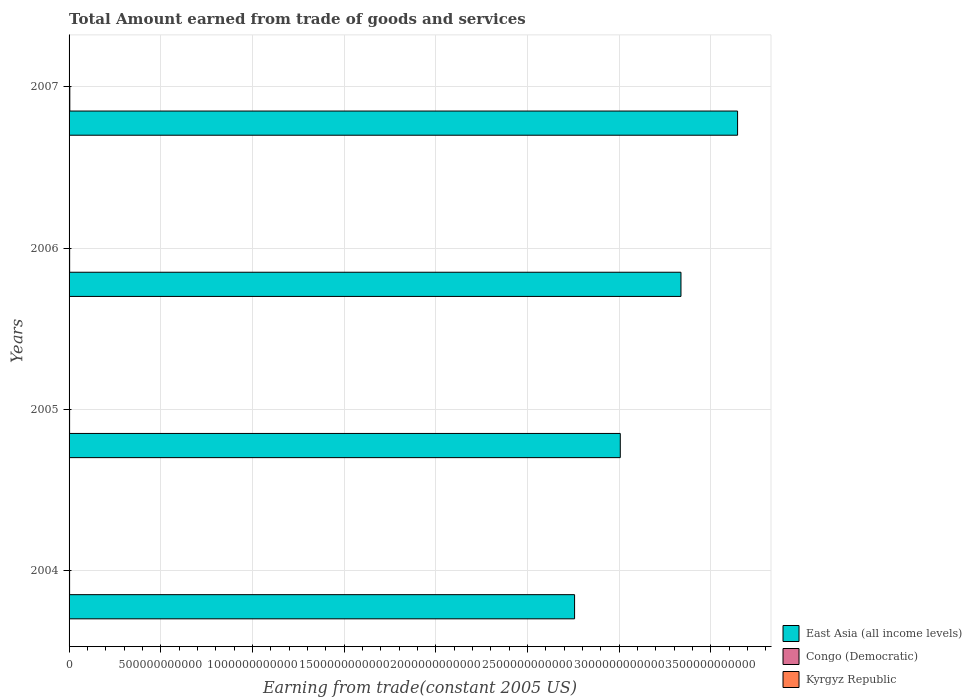How many different coloured bars are there?
Your answer should be very brief. 3. How many groups of bars are there?
Offer a very short reply. 4. How many bars are there on the 1st tick from the top?
Offer a terse response. 3. In how many cases, is the number of bars for a given year not equal to the number of legend labels?
Your response must be concise. 0. What is the total amount earned by trading goods and services in East Asia (all income levels) in 2007?
Provide a short and direct response. 3.65e+12. Across all years, what is the maximum total amount earned by trading goods and services in East Asia (all income levels)?
Offer a very short reply. 3.65e+12. Across all years, what is the minimum total amount earned by trading goods and services in Congo (Democratic)?
Your response must be concise. 2.82e+09. In which year was the total amount earned by trading goods and services in Kyrgyz Republic minimum?
Ensure brevity in your answer.  2004. What is the total total amount earned by trading goods and services in Congo (Democratic) in the graph?
Make the answer very short. 1.28e+1. What is the difference between the total amount earned by trading goods and services in East Asia (all income levels) in 2004 and that in 2007?
Provide a short and direct response. -8.89e+11. What is the difference between the total amount earned by trading goods and services in East Asia (all income levels) in 2004 and the total amount earned by trading goods and services in Congo (Democratic) in 2007?
Your answer should be compact. 2.75e+12. What is the average total amount earned by trading goods and services in East Asia (all income levels) per year?
Give a very brief answer. 3.19e+12. In the year 2005, what is the difference between the total amount earned by trading goods and services in Kyrgyz Republic and total amount earned by trading goods and services in East Asia (all income levels)?
Ensure brevity in your answer.  -3.00e+12. In how many years, is the total amount earned by trading goods and services in East Asia (all income levels) greater than 800000000000 US$?
Make the answer very short. 4. What is the ratio of the total amount earned by trading goods and services in East Asia (all income levels) in 2005 to that in 2006?
Offer a terse response. 0.9. What is the difference between the highest and the second highest total amount earned by trading goods and services in East Asia (all income levels)?
Give a very brief answer. 3.09e+11. What is the difference between the highest and the lowest total amount earned by trading goods and services in East Asia (all income levels)?
Ensure brevity in your answer.  8.89e+11. In how many years, is the total amount earned by trading goods and services in Congo (Democratic) greater than the average total amount earned by trading goods and services in Congo (Democratic) taken over all years?
Your answer should be compact. 1. What does the 3rd bar from the top in 2007 represents?
Your response must be concise. East Asia (all income levels). What does the 1st bar from the bottom in 2007 represents?
Offer a very short reply. East Asia (all income levels). Is it the case that in every year, the sum of the total amount earned by trading goods and services in Congo (Democratic) and total amount earned by trading goods and services in East Asia (all income levels) is greater than the total amount earned by trading goods and services in Kyrgyz Republic?
Keep it short and to the point. Yes. What is the difference between two consecutive major ticks on the X-axis?
Your answer should be very brief. 5.00e+11. Where does the legend appear in the graph?
Your answer should be compact. Bottom right. How are the legend labels stacked?
Make the answer very short. Vertical. What is the title of the graph?
Provide a short and direct response. Total Amount earned from trade of goods and services. Does "Burundi" appear as one of the legend labels in the graph?
Your answer should be very brief. No. What is the label or title of the X-axis?
Offer a very short reply. Earning from trade(constant 2005 US). What is the label or title of the Y-axis?
Ensure brevity in your answer.  Years. What is the Earning from trade(constant 2005 US) of East Asia (all income levels) in 2004?
Offer a very short reply. 2.76e+12. What is the Earning from trade(constant 2005 US) of Congo (Democratic) in 2004?
Provide a short and direct response. 2.84e+09. What is the Earning from trade(constant 2005 US) in Kyrgyz Republic in 2004?
Your response must be concise. 1.31e+09. What is the Earning from trade(constant 2005 US) of East Asia (all income levels) in 2005?
Provide a succinct answer. 3.01e+12. What is the Earning from trade(constant 2005 US) of Congo (Democratic) in 2005?
Provide a succinct answer. 2.82e+09. What is the Earning from trade(constant 2005 US) in Kyrgyz Republic in 2005?
Make the answer very short. 1.40e+09. What is the Earning from trade(constant 2005 US) in East Asia (all income levels) in 2006?
Ensure brevity in your answer.  3.34e+12. What is the Earning from trade(constant 2005 US) in Congo (Democratic) in 2006?
Your answer should be very brief. 3.10e+09. What is the Earning from trade(constant 2005 US) in Kyrgyz Republic in 2006?
Your response must be concise. 2.03e+09. What is the Earning from trade(constant 2005 US) of East Asia (all income levels) in 2007?
Your answer should be very brief. 3.65e+12. What is the Earning from trade(constant 2005 US) in Congo (Democratic) in 2007?
Your answer should be compact. 4.03e+09. What is the Earning from trade(constant 2005 US) in Kyrgyz Republic in 2007?
Offer a very short reply. 2.25e+09. Across all years, what is the maximum Earning from trade(constant 2005 US) of East Asia (all income levels)?
Keep it short and to the point. 3.65e+12. Across all years, what is the maximum Earning from trade(constant 2005 US) in Congo (Democratic)?
Offer a very short reply. 4.03e+09. Across all years, what is the maximum Earning from trade(constant 2005 US) of Kyrgyz Republic?
Ensure brevity in your answer.  2.25e+09. Across all years, what is the minimum Earning from trade(constant 2005 US) of East Asia (all income levels)?
Give a very brief answer. 2.76e+12. Across all years, what is the minimum Earning from trade(constant 2005 US) in Congo (Democratic)?
Provide a short and direct response. 2.82e+09. Across all years, what is the minimum Earning from trade(constant 2005 US) in Kyrgyz Republic?
Ensure brevity in your answer.  1.31e+09. What is the total Earning from trade(constant 2005 US) in East Asia (all income levels) in the graph?
Offer a terse response. 1.27e+13. What is the total Earning from trade(constant 2005 US) in Congo (Democratic) in the graph?
Offer a very short reply. 1.28e+1. What is the total Earning from trade(constant 2005 US) of Kyrgyz Republic in the graph?
Make the answer very short. 6.98e+09. What is the difference between the Earning from trade(constant 2005 US) in East Asia (all income levels) in 2004 and that in 2005?
Your answer should be compact. -2.49e+11. What is the difference between the Earning from trade(constant 2005 US) in Congo (Democratic) in 2004 and that in 2005?
Provide a succinct answer. 2.57e+07. What is the difference between the Earning from trade(constant 2005 US) in Kyrgyz Republic in 2004 and that in 2005?
Your answer should be very brief. -8.49e+07. What is the difference between the Earning from trade(constant 2005 US) of East Asia (all income levels) in 2004 and that in 2006?
Your answer should be compact. -5.80e+11. What is the difference between the Earning from trade(constant 2005 US) of Congo (Democratic) in 2004 and that in 2006?
Offer a very short reply. -2.57e+08. What is the difference between the Earning from trade(constant 2005 US) of Kyrgyz Republic in 2004 and that in 2006?
Give a very brief answer. -7.13e+08. What is the difference between the Earning from trade(constant 2005 US) of East Asia (all income levels) in 2004 and that in 2007?
Make the answer very short. -8.89e+11. What is the difference between the Earning from trade(constant 2005 US) of Congo (Democratic) in 2004 and that in 2007?
Offer a very short reply. -1.19e+09. What is the difference between the Earning from trade(constant 2005 US) of Kyrgyz Republic in 2004 and that in 2007?
Offer a very short reply. -9.36e+08. What is the difference between the Earning from trade(constant 2005 US) of East Asia (all income levels) in 2005 and that in 2006?
Ensure brevity in your answer.  -3.31e+11. What is the difference between the Earning from trade(constant 2005 US) in Congo (Democratic) in 2005 and that in 2006?
Provide a succinct answer. -2.82e+08. What is the difference between the Earning from trade(constant 2005 US) of Kyrgyz Republic in 2005 and that in 2006?
Make the answer very short. -6.28e+08. What is the difference between the Earning from trade(constant 2005 US) of East Asia (all income levels) in 2005 and that in 2007?
Provide a succinct answer. -6.40e+11. What is the difference between the Earning from trade(constant 2005 US) of Congo (Democratic) in 2005 and that in 2007?
Provide a short and direct response. -1.21e+09. What is the difference between the Earning from trade(constant 2005 US) of Kyrgyz Republic in 2005 and that in 2007?
Your answer should be compact. -8.51e+08. What is the difference between the Earning from trade(constant 2005 US) of East Asia (all income levels) in 2006 and that in 2007?
Offer a very short reply. -3.09e+11. What is the difference between the Earning from trade(constant 2005 US) in Congo (Democratic) in 2006 and that in 2007?
Your answer should be very brief. -9.32e+08. What is the difference between the Earning from trade(constant 2005 US) in Kyrgyz Republic in 2006 and that in 2007?
Ensure brevity in your answer.  -2.23e+08. What is the difference between the Earning from trade(constant 2005 US) of East Asia (all income levels) in 2004 and the Earning from trade(constant 2005 US) of Congo (Democratic) in 2005?
Your answer should be compact. 2.75e+12. What is the difference between the Earning from trade(constant 2005 US) in East Asia (all income levels) in 2004 and the Earning from trade(constant 2005 US) in Kyrgyz Republic in 2005?
Offer a very short reply. 2.76e+12. What is the difference between the Earning from trade(constant 2005 US) of Congo (Democratic) in 2004 and the Earning from trade(constant 2005 US) of Kyrgyz Republic in 2005?
Offer a very short reply. 1.45e+09. What is the difference between the Earning from trade(constant 2005 US) in East Asia (all income levels) in 2004 and the Earning from trade(constant 2005 US) in Congo (Democratic) in 2006?
Offer a very short reply. 2.75e+12. What is the difference between the Earning from trade(constant 2005 US) of East Asia (all income levels) in 2004 and the Earning from trade(constant 2005 US) of Kyrgyz Republic in 2006?
Provide a succinct answer. 2.75e+12. What is the difference between the Earning from trade(constant 2005 US) in Congo (Democratic) in 2004 and the Earning from trade(constant 2005 US) in Kyrgyz Republic in 2006?
Provide a succinct answer. 8.19e+08. What is the difference between the Earning from trade(constant 2005 US) of East Asia (all income levels) in 2004 and the Earning from trade(constant 2005 US) of Congo (Democratic) in 2007?
Your response must be concise. 2.75e+12. What is the difference between the Earning from trade(constant 2005 US) of East Asia (all income levels) in 2004 and the Earning from trade(constant 2005 US) of Kyrgyz Republic in 2007?
Provide a short and direct response. 2.75e+12. What is the difference between the Earning from trade(constant 2005 US) of Congo (Democratic) in 2004 and the Earning from trade(constant 2005 US) of Kyrgyz Republic in 2007?
Provide a short and direct response. 5.96e+08. What is the difference between the Earning from trade(constant 2005 US) of East Asia (all income levels) in 2005 and the Earning from trade(constant 2005 US) of Congo (Democratic) in 2006?
Keep it short and to the point. 3.00e+12. What is the difference between the Earning from trade(constant 2005 US) of East Asia (all income levels) in 2005 and the Earning from trade(constant 2005 US) of Kyrgyz Republic in 2006?
Provide a short and direct response. 3.00e+12. What is the difference between the Earning from trade(constant 2005 US) in Congo (Democratic) in 2005 and the Earning from trade(constant 2005 US) in Kyrgyz Republic in 2006?
Offer a terse response. 7.94e+08. What is the difference between the Earning from trade(constant 2005 US) of East Asia (all income levels) in 2005 and the Earning from trade(constant 2005 US) of Congo (Democratic) in 2007?
Offer a very short reply. 3.00e+12. What is the difference between the Earning from trade(constant 2005 US) of East Asia (all income levels) in 2005 and the Earning from trade(constant 2005 US) of Kyrgyz Republic in 2007?
Keep it short and to the point. 3.00e+12. What is the difference between the Earning from trade(constant 2005 US) in Congo (Democratic) in 2005 and the Earning from trade(constant 2005 US) in Kyrgyz Republic in 2007?
Keep it short and to the point. 5.71e+08. What is the difference between the Earning from trade(constant 2005 US) of East Asia (all income levels) in 2006 and the Earning from trade(constant 2005 US) of Congo (Democratic) in 2007?
Your answer should be very brief. 3.33e+12. What is the difference between the Earning from trade(constant 2005 US) of East Asia (all income levels) in 2006 and the Earning from trade(constant 2005 US) of Kyrgyz Republic in 2007?
Provide a succinct answer. 3.33e+12. What is the difference between the Earning from trade(constant 2005 US) of Congo (Democratic) in 2006 and the Earning from trade(constant 2005 US) of Kyrgyz Republic in 2007?
Provide a short and direct response. 8.53e+08. What is the average Earning from trade(constant 2005 US) in East Asia (all income levels) per year?
Offer a very short reply. 3.19e+12. What is the average Earning from trade(constant 2005 US) in Congo (Democratic) per year?
Keep it short and to the point. 3.20e+09. What is the average Earning from trade(constant 2005 US) in Kyrgyz Republic per year?
Provide a succinct answer. 1.75e+09. In the year 2004, what is the difference between the Earning from trade(constant 2005 US) of East Asia (all income levels) and Earning from trade(constant 2005 US) of Congo (Democratic)?
Provide a short and direct response. 2.75e+12. In the year 2004, what is the difference between the Earning from trade(constant 2005 US) in East Asia (all income levels) and Earning from trade(constant 2005 US) in Kyrgyz Republic?
Your answer should be very brief. 2.76e+12. In the year 2004, what is the difference between the Earning from trade(constant 2005 US) of Congo (Democratic) and Earning from trade(constant 2005 US) of Kyrgyz Republic?
Ensure brevity in your answer.  1.53e+09. In the year 2005, what is the difference between the Earning from trade(constant 2005 US) of East Asia (all income levels) and Earning from trade(constant 2005 US) of Congo (Democratic)?
Provide a succinct answer. 3.00e+12. In the year 2005, what is the difference between the Earning from trade(constant 2005 US) in East Asia (all income levels) and Earning from trade(constant 2005 US) in Kyrgyz Republic?
Give a very brief answer. 3.00e+12. In the year 2005, what is the difference between the Earning from trade(constant 2005 US) of Congo (Democratic) and Earning from trade(constant 2005 US) of Kyrgyz Republic?
Give a very brief answer. 1.42e+09. In the year 2006, what is the difference between the Earning from trade(constant 2005 US) of East Asia (all income levels) and Earning from trade(constant 2005 US) of Congo (Democratic)?
Offer a terse response. 3.33e+12. In the year 2006, what is the difference between the Earning from trade(constant 2005 US) of East Asia (all income levels) and Earning from trade(constant 2005 US) of Kyrgyz Republic?
Your response must be concise. 3.33e+12. In the year 2006, what is the difference between the Earning from trade(constant 2005 US) of Congo (Democratic) and Earning from trade(constant 2005 US) of Kyrgyz Republic?
Offer a very short reply. 1.08e+09. In the year 2007, what is the difference between the Earning from trade(constant 2005 US) in East Asia (all income levels) and Earning from trade(constant 2005 US) in Congo (Democratic)?
Provide a succinct answer. 3.64e+12. In the year 2007, what is the difference between the Earning from trade(constant 2005 US) of East Asia (all income levels) and Earning from trade(constant 2005 US) of Kyrgyz Republic?
Offer a very short reply. 3.64e+12. In the year 2007, what is the difference between the Earning from trade(constant 2005 US) of Congo (Democratic) and Earning from trade(constant 2005 US) of Kyrgyz Republic?
Your answer should be compact. 1.79e+09. What is the ratio of the Earning from trade(constant 2005 US) of East Asia (all income levels) in 2004 to that in 2005?
Your answer should be very brief. 0.92. What is the ratio of the Earning from trade(constant 2005 US) of Congo (Democratic) in 2004 to that in 2005?
Your answer should be very brief. 1.01. What is the ratio of the Earning from trade(constant 2005 US) in Kyrgyz Republic in 2004 to that in 2005?
Your answer should be compact. 0.94. What is the ratio of the Earning from trade(constant 2005 US) in East Asia (all income levels) in 2004 to that in 2006?
Provide a succinct answer. 0.83. What is the ratio of the Earning from trade(constant 2005 US) in Congo (Democratic) in 2004 to that in 2006?
Ensure brevity in your answer.  0.92. What is the ratio of the Earning from trade(constant 2005 US) of Kyrgyz Republic in 2004 to that in 2006?
Your answer should be very brief. 0.65. What is the ratio of the Earning from trade(constant 2005 US) of East Asia (all income levels) in 2004 to that in 2007?
Give a very brief answer. 0.76. What is the ratio of the Earning from trade(constant 2005 US) in Congo (Democratic) in 2004 to that in 2007?
Your answer should be very brief. 0.71. What is the ratio of the Earning from trade(constant 2005 US) of Kyrgyz Republic in 2004 to that in 2007?
Ensure brevity in your answer.  0.58. What is the ratio of the Earning from trade(constant 2005 US) in East Asia (all income levels) in 2005 to that in 2006?
Your answer should be compact. 0.9. What is the ratio of the Earning from trade(constant 2005 US) of Congo (Democratic) in 2005 to that in 2006?
Ensure brevity in your answer.  0.91. What is the ratio of the Earning from trade(constant 2005 US) in Kyrgyz Republic in 2005 to that in 2006?
Keep it short and to the point. 0.69. What is the ratio of the Earning from trade(constant 2005 US) in East Asia (all income levels) in 2005 to that in 2007?
Provide a short and direct response. 0.82. What is the ratio of the Earning from trade(constant 2005 US) of Congo (Democratic) in 2005 to that in 2007?
Keep it short and to the point. 0.7. What is the ratio of the Earning from trade(constant 2005 US) in Kyrgyz Republic in 2005 to that in 2007?
Your answer should be very brief. 0.62. What is the ratio of the Earning from trade(constant 2005 US) of East Asia (all income levels) in 2006 to that in 2007?
Ensure brevity in your answer.  0.92. What is the ratio of the Earning from trade(constant 2005 US) in Congo (Democratic) in 2006 to that in 2007?
Offer a very short reply. 0.77. What is the ratio of the Earning from trade(constant 2005 US) of Kyrgyz Republic in 2006 to that in 2007?
Offer a very short reply. 0.9. What is the difference between the highest and the second highest Earning from trade(constant 2005 US) in East Asia (all income levels)?
Give a very brief answer. 3.09e+11. What is the difference between the highest and the second highest Earning from trade(constant 2005 US) of Congo (Democratic)?
Provide a succinct answer. 9.32e+08. What is the difference between the highest and the second highest Earning from trade(constant 2005 US) in Kyrgyz Republic?
Keep it short and to the point. 2.23e+08. What is the difference between the highest and the lowest Earning from trade(constant 2005 US) of East Asia (all income levels)?
Give a very brief answer. 8.89e+11. What is the difference between the highest and the lowest Earning from trade(constant 2005 US) in Congo (Democratic)?
Your answer should be very brief. 1.21e+09. What is the difference between the highest and the lowest Earning from trade(constant 2005 US) of Kyrgyz Republic?
Your answer should be very brief. 9.36e+08. 